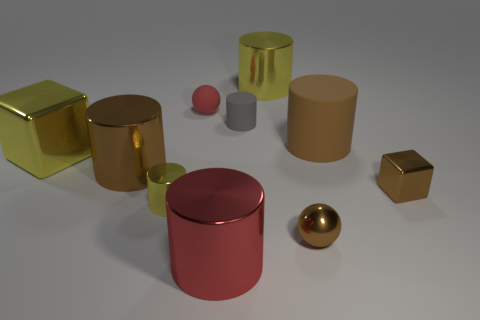Subtract all gray cylinders. How many cylinders are left? 5 Subtract all small yellow cylinders. How many cylinders are left? 5 Subtract all green cylinders. Subtract all yellow balls. How many cylinders are left? 6 Subtract all spheres. How many objects are left? 8 Add 9 green objects. How many green objects exist? 9 Subtract 0 cyan cylinders. How many objects are left? 10 Subtract all metal cylinders. Subtract all tiny cylinders. How many objects are left? 4 Add 5 large red shiny objects. How many large red shiny objects are left? 6 